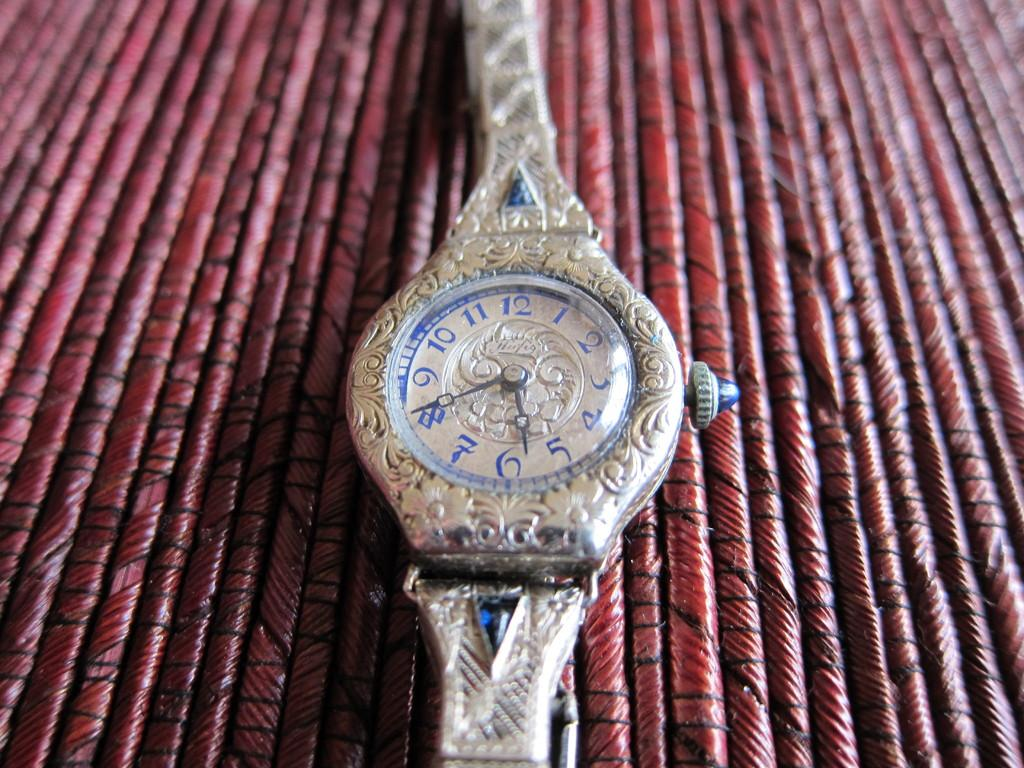<image>
Relay a brief, clear account of the picture shown. A watch on a red twine table has the number 8 on it 